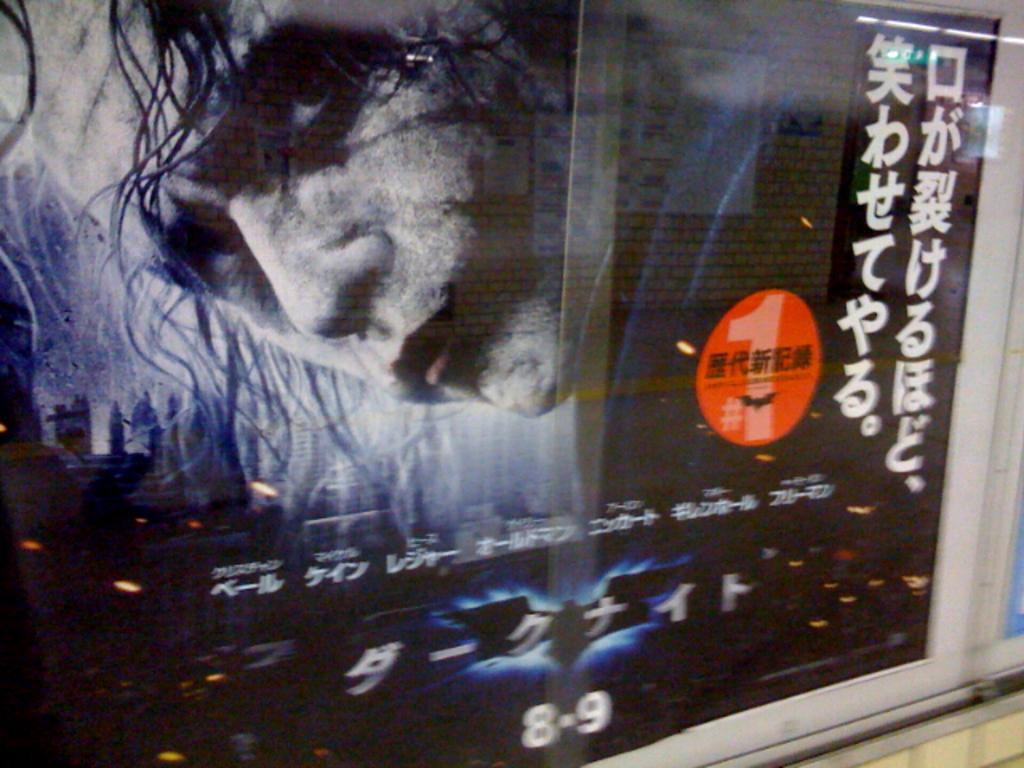<image>
Describe the image concisely. A movie poster has the numbers 8-9 at the bottom. 